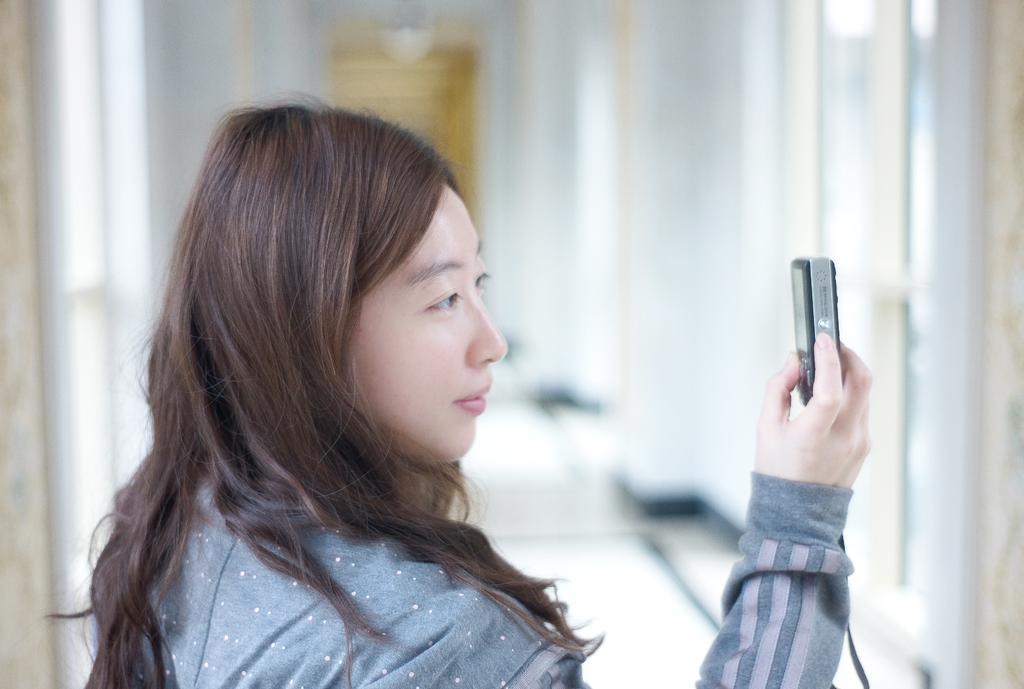Describe this image in one or two sentences. There is a lady in the image, holding a camera in her hand and clicking a photos, who's wearing a blue color jacket with a long hair. In the background top, we can see a chandelier hanging on the wall. In the background middle, we can see a door with light yellow in color. Both sides of the image, we can see a wall with white in color. 